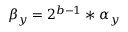Convert formula to latex. <formula><loc_0><loc_0><loc_500><loc_500>\beta _ { y } = 2 ^ { b - 1 } * \alpha _ { y }</formula> 